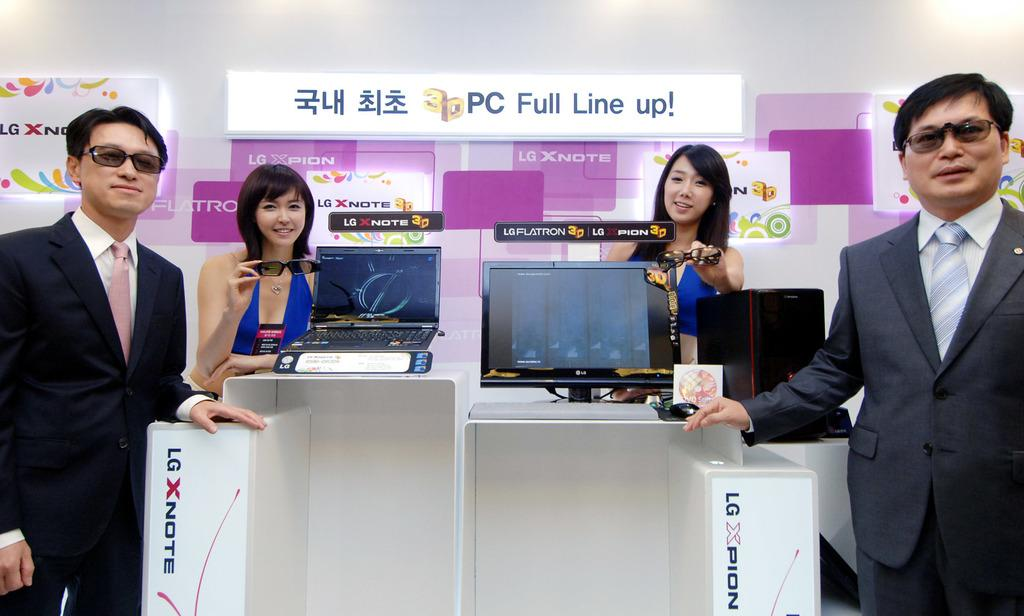How many people are present in the image? There are four persons standing in the image. What are two of the persons holding? Two of the persons are holding spectacles. What can be seen on the table in the image? There are two laptops on a table in the image. Can you describe anything visible in the background of the image? There is some text visible in the background of the image. What type of wealth is being displayed in the image? There is no indication of wealth being displayed in the image; it features four persons, spectacles, laptops, and text in the background. Is the image taken during winter, and if so, how can you tell? The image does not provide any information about the season or weather, so it cannot be determined if it was taken during winter. 